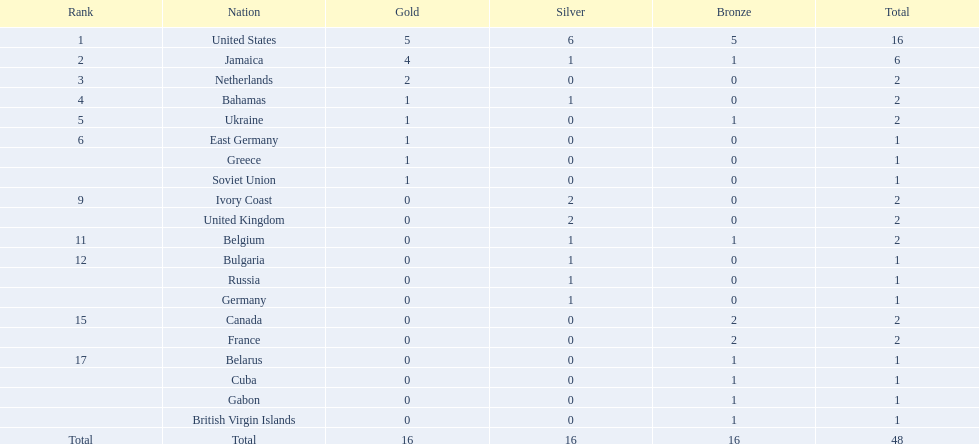How many countries secured more than one silver medal? 3. 